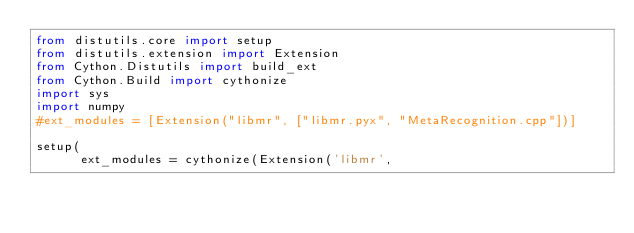Convert code to text. <code><loc_0><loc_0><loc_500><loc_500><_Python_>from distutils.core import setup
from distutils.extension import Extension
from Cython.Distutils import build_ext
from Cython.Build import cythonize
import sys
import numpy
#ext_modules = [Extension("libmr", ["libmr.pyx", "MetaRecognition.cpp"])]

setup(
      ext_modules = cythonize(Extension('libmr',</code> 